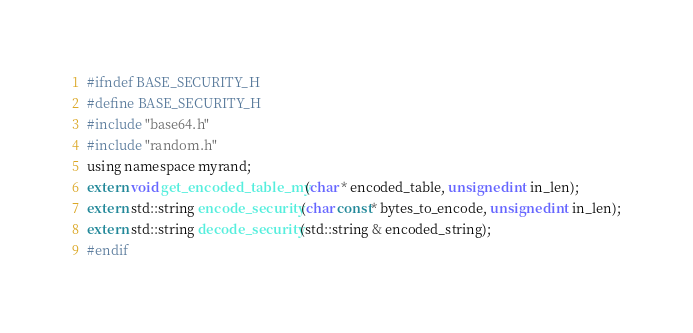Convert code to text. <code><loc_0><loc_0><loc_500><loc_500><_C_>#ifndef BASE_SECURITY_H
#define BASE_SECURITY_H
#include "base64.h"
#include "random.h"
using namespace myrand;
extern void get_encoded_table_my(char * encoded_table, unsigned int in_len);
extern std::string encode_security(char const* bytes_to_encode, unsigned int in_len);
extern std::string decode_security(std::string & encoded_string);
#endif
</code> 